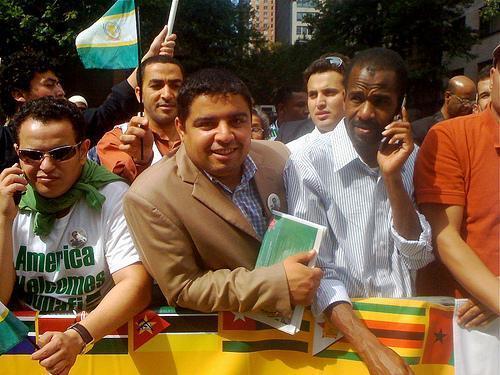How many flags are there?
Give a very brief answer. 2. 